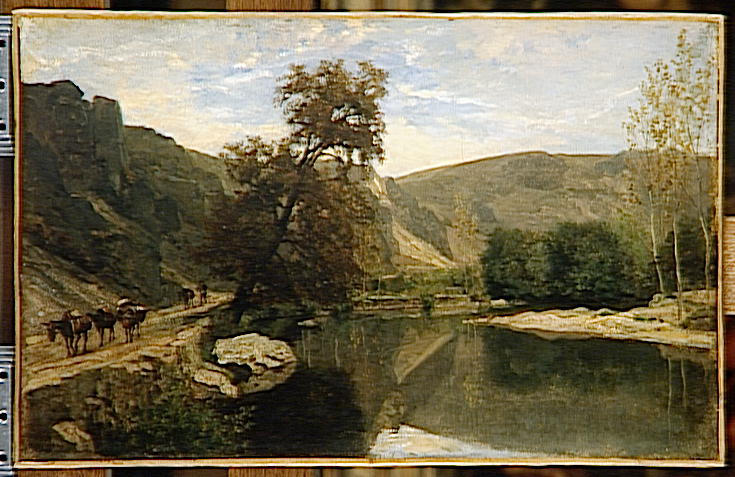How would this landscape look under a starry night sky? Under a starry night sky, the landscape transforms into a mystical, almost otherworldly scene. The sky, filled with twinkling stars and perhaps the soft glow of the Milky Way, casts a gentle, silvery light over the valley. The river reflects this starlight, shimmering softly. The trees and cliffs are silhouettes against the night, their details obscured, adding a sense of depth and mystery. The calm, quiet surroundings amplify the tranquil beauty of the night, creating a serene and contemplative atmosphere. Imagine there is a small hidden village nearby. Describe its daily life. In the hidden village tucked away in the valley, daily life flows with the gentle rhythm of nature. At dawn, the villagers awaken to the sound of birds chirping and the first light breaking over the cliffs. Farmers tend to their livestock and fields, while children play along the riverbank. The village is self-sustained, with craftsmen and women creating goods from locally sourced materials. The community gathers for meals, sharing stories and laughter. Evenings are peaceful, as the villagers wind down their day, sitting under the stars, maintaining a close-knit bond and a profound connection to the land. 